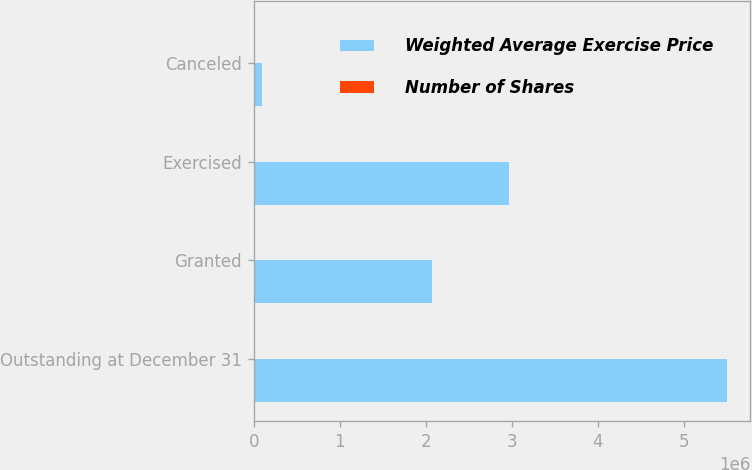<chart> <loc_0><loc_0><loc_500><loc_500><stacked_bar_chart><ecel><fcel>Outstanding at December 31<fcel>Granted<fcel>Exercised<fcel>Canceled<nl><fcel>Weighted Average Exercise Price<fcel>5.4955e+06<fcel>2.0673e+06<fcel>2.96355e+06<fcel>96886<nl><fcel>Number of Shares<fcel>49.43<fcel>33.28<fcel>17.17<fcel>30.78<nl></chart> 